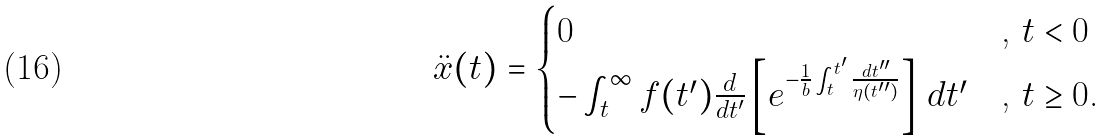<formula> <loc_0><loc_0><loc_500><loc_500>\ddot { x } ( t ) = \begin{cases} 0 & \text {, $t<0$} \\ - \int _ { t } ^ { \infty } f ( t ^ { \prime } ) \frac { d } { d t ^ { \prime } } \left [ e ^ { - \frac { 1 } { b } \int _ { t } ^ { t ^ { \prime } } \frac { d t ^ { \prime \prime } } { \eta ( t ^ { \prime \prime } ) } } \right ] \, d t ^ { \prime } & \text {, $t \geq 0$.} \end{cases}</formula> 